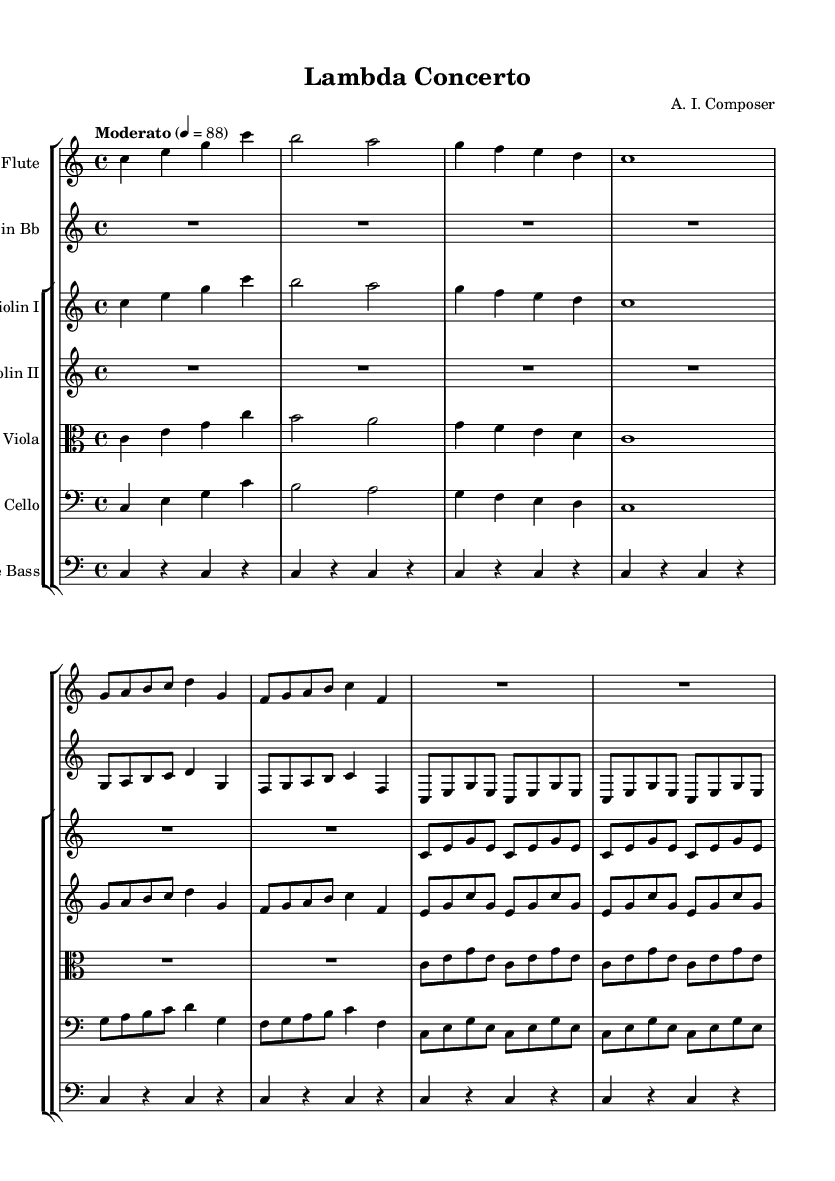What is the key signature of this music? The key signature is C major, indicated by the absence of sharps or flats at the beginning of the staff.
Answer: C major What is the time signature of this piece? The time signature is 4/4, which is shown at the beginning of the score after the key signature. It means there are four beats in each measure, and each beat is a quarter note.
Answer: 4/4 What is the tempo marking for the symphony? The tempo marking is "Moderato," which indicates a moderate pace for performance. This is found above the staff indicating how the piece should be played.
Answer: Moderato How many measures are there in the flute part? The flute part has a total of 8 measures, as each set of bars indicates one measure, and counting the groups shows there are 8.
Answer: 8 Which instruments are featured in this symphony? The instruments featured are Flute, Clarinet, Violin I, Violin II, Viola, Cello, and Double Bass, as indicated in the staff group headers.
Answer: Flute, Clarinet, Violin I, Violin II, Viola, Cello, Double Bass What melodic technique is primarily used in the violin parts? The violin parts prominently feature arpeggios and repeated notes, which create a cascading effect, analyzed by reviewing the repeated patterns within the measures.
Answer: Arpeggios What is the relation of the clarinet part to the flute part? The clarinet part transposes down a major second (B flat), which means it sounds a whole step lower than written, evident through comparing pitch notations across the two parts.
Answer: Transposing 